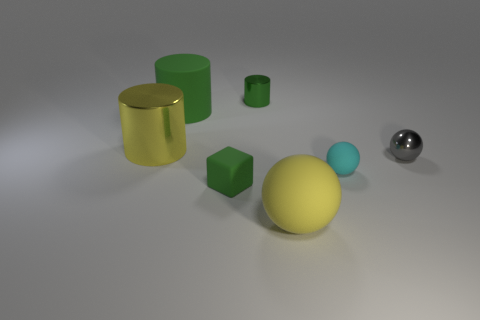Add 1 tiny green cylinders. How many objects exist? 8 Subtract all tiny spheres. How many spheres are left? 1 Subtract all cubes. How many objects are left? 6 Subtract all yellow cylinders. How many cylinders are left? 2 Add 3 big yellow rubber balls. How many big yellow rubber balls are left? 4 Add 7 cyan matte spheres. How many cyan matte spheres exist? 8 Subtract 0 green balls. How many objects are left? 7 Subtract 2 cylinders. How many cylinders are left? 1 Subtract all red spheres. Subtract all purple blocks. How many spheres are left? 3 Subtract all green cylinders. How many cyan balls are left? 1 